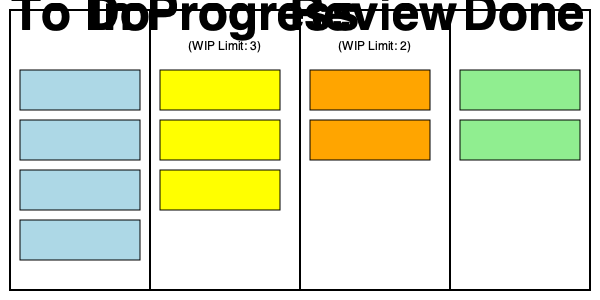Based on the Kanban board shown, which of the following actions would violate the work-in-progress (WIP) limits?

A) Moving a task from "To Do" to "In Progress"
B) Moving a task from "In Progress" to "Review"
C) Moving a task from "Review" to "Done"
D) Moving a task from "To Do" to "Review" To answer this question, we need to analyze the Kanban board and understand the work-in-progress (WIP) limits for each column. Let's break it down step-by-step:

1. Observe the board layout:
   - The board has four columns: To Do, In Progress, Review, and Done.
   - WIP limits are specified for two columns:
     - In Progress: WIP Limit of 3
     - Review: WIP Limit of 2

2. Count the current tasks in each column:
   - To Do: 4 tasks
   - In Progress: 3 tasks (at WIP limit)
   - Review: 2 tasks (at WIP limit)
   - Done: 2 tasks

3. Analyze each option:
   A) Moving a task from "To Do" to "In Progress":
      - This would add a 4th task to "In Progress", exceeding its WIP limit of 3.
   
   B) Moving a task from "In Progress" to "Review":
      - This would add a 3rd task to "Review", exceeding its WIP limit of 2.
   
   C) Moving a task from "Review" to "Done":
      - This would reduce the number of tasks in "Review" to 1, which is within the WIP limit.
      - The "Done" column has no WIP limit, so adding a task here is allowed.
   
   D) Moving a task from "To Do" to "Review":
      - This would add a 3rd task to "Review", exceeding its WIP limit of 2.
      - Additionally, this move skips the "In Progress" column, which is not a typical Kanban workflow.

4. Identify the violations:
   - Options A, B, and D would all violate WIP limits.
   - Option C does not violate any WIP limits.

Therefore, the correct answer includes all options except C.
Answer: A, B, and D 